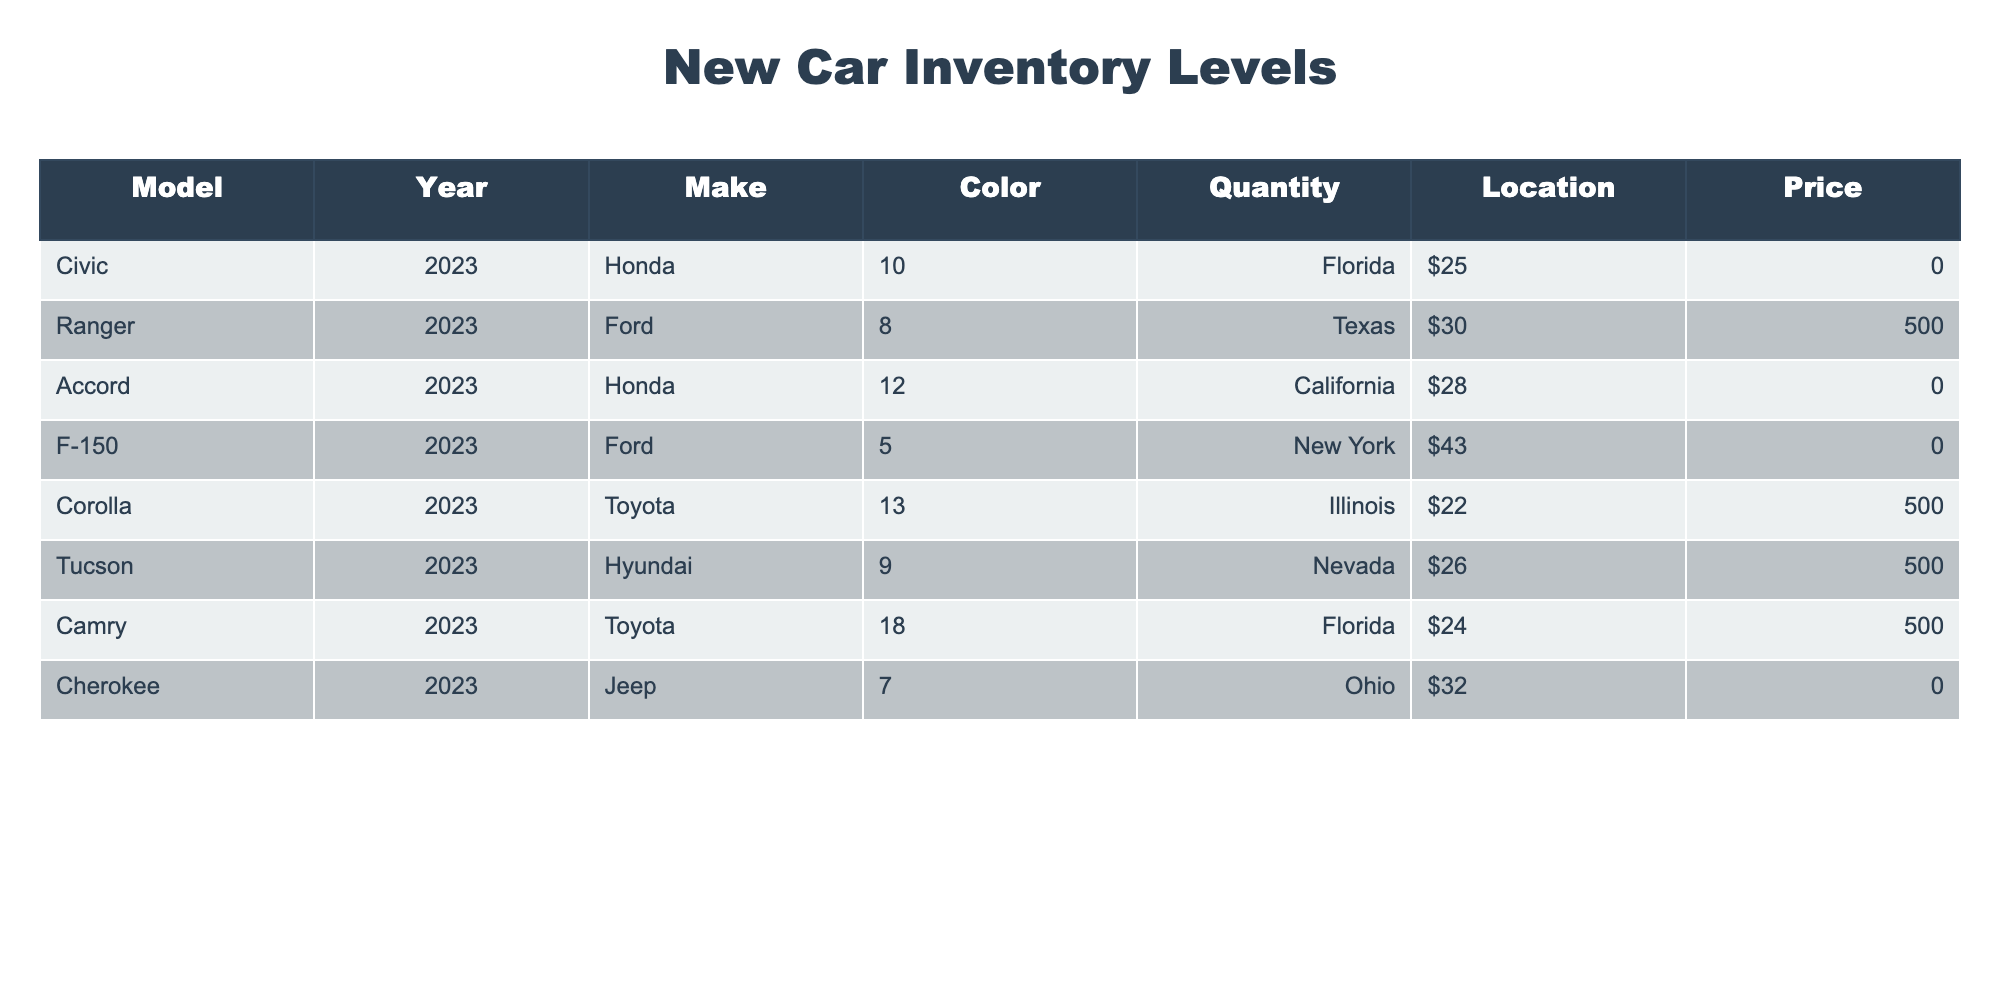What is the quantity of Civics available? The table lists the inventory for different car models, and the row for the Civic shows a quantity of 10.
Answer: 10 Which car model has the highest quantity? By examining the quantities listed for each model, the Camry has the highest quantity of 18.
Answer: Camry What is the average price of all the cars in the inventory? To calculate the average price, add all the prices: (25000 + 30500 + 28000 + 43000 + 22500 + 26500 + 24500 + 32000) = 202500. There are 8 cars, so the average price is 202500 / 8 = 25312.50.
Answer: $25,312.50 Is there a Ford model that has more than 10 units available? Looking at the Ranger (8) and the F-150 (5), both Ford models have less than 10 units available. Therefore, the answer is no.
Answer: No Which make has the least quantity of cars available? Checking the quantities, the Jeep Cherokee has a quantity of 7, which is the lowest compared to the other makes listed.
Answer: Jeep How many cars are there in total from Honda? The Honda models in the table are the Civic (10) and Accord (12). Summing these gives 10 + 12 = 22.
Answer: 22 Is there a Toyota model available in blue? The table shows the Corolla as a blue Toyota model. Therefore, the answer is yes.
Answer: Yes What is the total quantity of Hyundai cars in the inventory? There is only one Hyundai model listed, the Tucson, with a quantity of 9. Thus, the total quantity is 9.
Answer: 9 Which location has the most cars available? By comparing the quantities by location, Florida has the Camry with 18, which is higher than any other locations.
Answer: Florida 